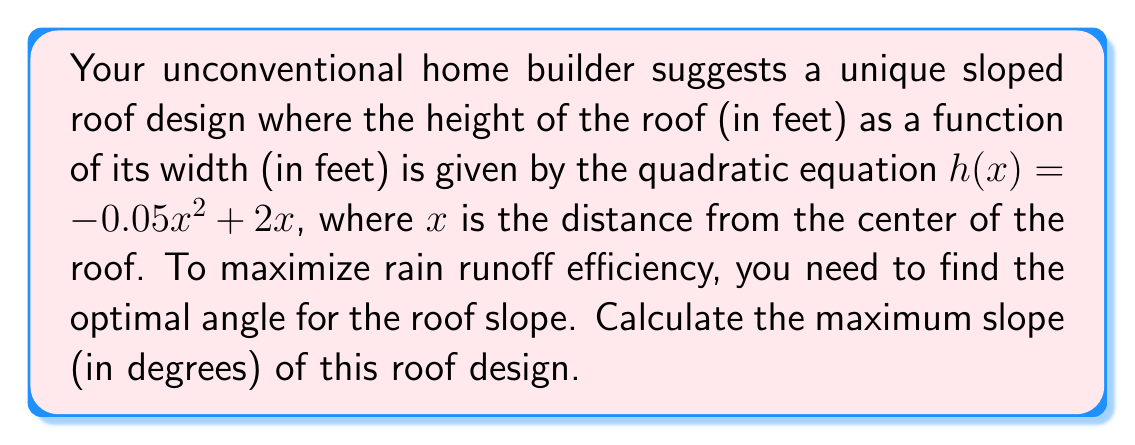Could you help me with this problem? To find the maximum slope of the roof, we need to follow these steps:

1) The slope of the roof at any point is given by the derivative of the height function:
   $h'(x) = -0.1x + 2$

2) The maximum slope will occur where the second derivative equals zero:
   $h''(x) = -0.1$
   This is always negative, so the maximum slope occurs at the edge of the roof.

3) To find the edge of the roof, we need to find where $h(x) = 0$:
   $-0.05x^2 + 2x = 0$
   $x(-0.05x + 2) = 0$
   $x = 0$ or $x = 40$

4) The edge of the roof is at $x = 40$ (since $x = 0$ is the center).

5) Calculate the slope at $x = 40$:
   $h'(40) = -0.1(40) + 2 = -2$

6) The slope is the tangent of the angle. To convert to degrees:
   $\theta = \arctan(-2)$

7) Convert to degrees:
   $\theta = \arctan(-2) * \frac{180}{\pi} \approx -63.43°$

8) Take the absolute value for the final answer:
   $|\theta| \approx 63.43°$
Answer: 63.43° 